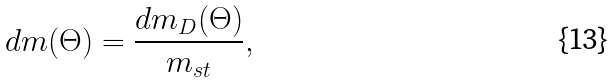<formula> <loc_0><loc_0><loc_500><loc_500>d m ( \Theta ) = \frac { d m _ { D } ( \Theta ) } { m _ { s t } } ,</formula> 